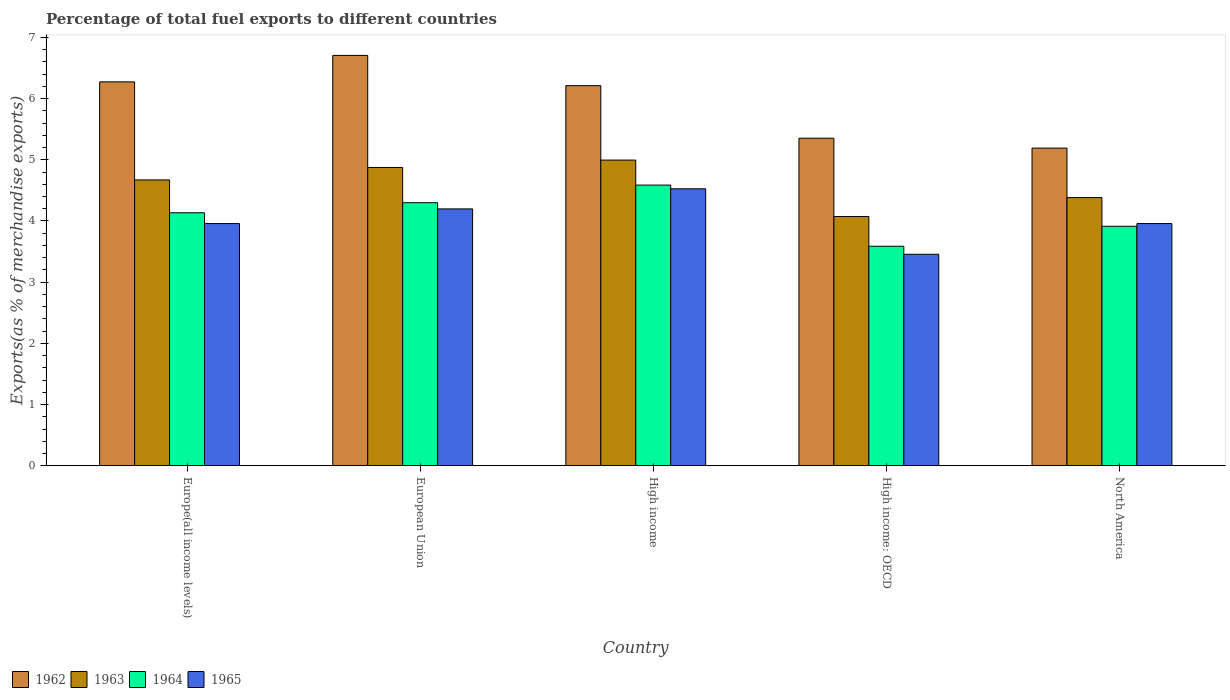Are the number of bars per tick equal to the number of legend labels?
Ensure brevity in your answer.  Yes. Are the number of bars on each tick of the X-axis equal?
Make the answer very short. Yes. How many bars are there on the 3rd tick from the left?
Offer a terse response. 4. How many bars are there on the 3rd tick from the right?
Provide a succinct answer. 4. What is the label of the 3rd group of bars from the left?
Offer a very short reply. High income. What is the percentage of exports to different countries in 1964 in High income?
Your answer should be very brief. 4.59. Across all countries, what is the maximum percentage of exports to different countries in 1962?
Ensure brevity in your answer.  6.71. Across all countries, what is the minimum percentage of exports to different countries in 1964?
Your answer should be very brief. 3.59. In which country was the percentage of exports to different countries in 1965 minimum?
Ensure brevity in your answer.  High income: OECD. What is the total percentage of exports to different countries in 1962 in the graph?
Keep it short and to the point. 29.73. What is the difference between the percentage of exports to different countries in 1962 in High income: OECD and that in North America?
Your answer should be very brief. 0.16. What is the difference between the percentage of exports to different countries in 1965 in High income: OECD and the percentage of exports to different countries in 1964 in North America?
Make the answer very short. -0.46. What is the average percentage of exports to different countries in 1963 per country?
Provide a succinct answer. 4.6. What is the difference between the percentage of exports to different countries of/in 1965 and percentage of exports to different countries of/in 1962 in North America?
Offer a very short reply. -1.23. In how many countries, is the percentage of exports to different countries in 1963 greater than 5.6 %?
Your response must be concise. 0. What is the ratio of the percentage of exports to different countries in 1965 in High income to that in High income: OECD?
Make the answer very short. 1.31. Is the percentage of exports to different countries in 1964 in High income: OECD less than that in North America?
Provide a short and direct response. Yes. Is the difference between the percentage of exports to different countries in 1965 in European Union and North America greater than the difference between the percentage of exports to different countries in 1962 in European Union and North America?
Make the answer very short. No. What is the difference between the highest and the second highest percentage of exports to different countries in 1963?
Provide a short and direct response. -0.32. What is the difference between the highest and the lowest percentage of exports to different countries in 1964?
Your answer should be very brief. 1. What does the 4th bar from the left in North America represents?
Keep it short and to the point. 1965. What does the 4th bar from the right in North America represents?
Ensure brevity in your answer.  1962. Are all the bars in the graph horizontal?
Offer a very short reply. No. What is the difference between two consecutive major ticks on the Y-axis?
Provide a succinct answer. 1. Are the values on the major ticks of Y-axis written in scientific E-notation?
Give a very brief answer. No. Does the graph contain any zero values?
Provide a succinct answer. No. How are the legend labels stacked?
Keep it short and to the point. Horizontal. What is the title of the graph?
Your response must be concise. Percentage of total fuel exports to different countries. What is the label or title of the X-axis?
Give a very brief answer. Country. What is the label or title of the Y-axis?
Provide a short and direct response. Exports(as % of merchandise exports). What is the Exports(as % of merchandise exports) in 1962 in Europe(all income levels)?
Provide a short and direct response. 6.27. What is the Exports(as % of merchandise exports) in 1963 in Europe(all income levels)?
Ensure brevity in your answer.  4.67. What is the Exports(as % of merchandise exports) of 1964 in Europe(all income levels)?
Ensure brevity in your answer.  4.13. What is the Exports(as % of merchandise exports) of 1965 in Europe(all income levels)?
Keep it short and to the point. 3.96. What is the Exports(as % of merchandise exports) of 1962 in European Union?
Keep it short and to the point. 6.71. What is the Exports(as % of merchandise exports) in 1963 in European Union?
Provide a short and direct response. 4.87. What is the Exports(as % of merchandise exports) in 1964 in European Union?
Your answer should be very brief. 4.3. What is the Exports(as % of merchandise exports) in 1965 in European Union?
Ensure brevity in your answer.  4.2. What is the Exports(as % of merchandise exports) in 1962 in High income?
Offer a very short reply. 6.21. What is the Exports(as % of merchandise exports) of 1963 in High income?
Your answer should be compact. 5. What is the Exports(as % of merchandise exports) of 1964 in High income?
Your answer should be compact. 4.59. What is the Exports(as % of merchandise exports) in 1965 in High income?
Give a very brief answer. 4.53. What is the Exports(as % of merchandise exports) of 1962 in High income: OECD?
Give a very brief answer. 5.35. What is the Exports(as % of merchandise exports) in 1963 in High income: OECD?
Your response must be concise. 4.07. What is the Exports(as % of merchandise exports) of 1964 in High income: OECD?
Provide a succinct answer. 3.59. What is the Exports(as % of merchandise exports) in 1965 in High income: OECD?
Keep it short and to the point. 3.46. What is the Exports(as % of merchandise exports) of 1962 in North America?
Your response must be concise. 5.19. What is the Exports(as % of merchandise exports) of 1963 in North America?
Offer a very short reply. 4.38. What is the Exports(as % of merchandise exports) in 1964 in North America?
Your answer should be very brief. 3.91. What is the Exports(as % of merchandise exports) in 1965 in North America?
Provide a short and direct response. 3.96. Across all countries, what is the maximum Exports(as % of merchandise exports) in 1962?
Offer a very short reply. 6.71. Across all countries, what is the maximum Exports(as % of merchandise exports) in 1963?
Keep it short and to the point. 5. Across all countries, what is the maximum Exports(as % of merchandise exports) of 1964?
Make the answer very short. 4.59. Across all countries, what is the maximum Exports(as % of merchandise exports) in 1965?
Give a very brief answer. 4.53. Across all countries, what is the minimum Exports(as % of merchandise exports) in 1962?
Your answer should be very brief. 5.19. Across all countries, what is the minimum Exports(as % of merchandise exports) of 1963?
Your response must be concise. 4.07. Across all countries, what is the minimum Exports(as % of merchandise exports) of 1964?
Make the answer very short. 3.59. Across all countries, what is the minimum Exports(as % of merchandise exports) of 1965?
Provide a succinct answer. 3.46. What is the total Exports(as % of merchandise exports) in 1962 in the graph?
Provide a succinct answer. 29.73. What is the total Exports(as % of merchandise exports) of 1963 in the graph?
Provide a succinct answer. 23. What is the total Exports(as % of merchandise exports) in 1964 in the graph?
Give a very brief answer. 20.52. What is the total Exports(as % of merchandise exports) of 1965 in the graph?
Your answer should be very brief. 20.09. What is the difference between the Exports(as % of merchandise exports) of 1962 in Europe(all income levels) and that in European Union?
Give a very brief answer. -0.43. What is the difference between the Exports(as % of merchandise exports) in 1963 in Europe(all income levels) and that in European Union?
Your response must be concise. -0.2. What is the difference between the Exports(as % of merchandise exports) of 1964 in Europe(all income levels) and that in European Union?
Give a very brief answer. -0.16. What is the difference between the Exports(as % of merchandise exports) of 1965 in Europe(all income levels) and that in European Union?
Ensure brevity in your answer.  -0.24. What is the difference between the Exports(as % of merchandise exports) of 1962 in Europe(all income levels) and that in High income?
Your response must be concise. 0.06. What is the difference between the Exports(as % of merchandise exports) of 1963 in Europe(all income levels) and that in High income?
Provide a succinct answer. -0.32. What is the difference between the Exports(as % of merchandise exports) of 1964 in Europe(all income levels) and that in High income?
Your answer should be compact. -0.45. What is the difference between the Exports(as % of merchandise exports) of 1965 in Europe(all income levels) and that in High income?
Provide a short and direct response. -0.57. What is the difference between the Exports(as % of merchandise exports) in 1962 in Europe(all income levels) and that in High income: OECD?
Your answer should be very brief. 0.92. What is the difference between the Exports(as % of merchandise exports) in 1963 in Europe(all income levels) and that in High income: OECD?
Ensure brevity in your answer.  0.6. What is the difference between the Exports(as % of merchandise exports) of 1964 in Europe(all income levels) and that in High income: OECD?
Provide a succinct answer. 0.55. What is the difference between the Exports(as % of merchandise exports) in 1965 in Europe(all income levels) and that in High income: OECD?
Your answer should be compact. 0.5. What is the difference between the Exports(as % of merchandise exports) of 1962 in Europe(all income levels) and that in North America?
Your answer should be compact. 1.08. What is the difference between the Exports(as % of merchandise exports) of 1963 in Europe(all income levels) and that in North America?
Make the answer very short. 0.29. What is the difference between the Exports(as % of merchandise exports) in 1964 in Europe(all income levels) and that in North America?
Your answer should be compact. 0.22. What is the difference between the Exports(as % of merchandise exports) of 1965 in Europe(all income levels) and that in North America?
Your response must be concise. 0. What is the difference between the Exports(as % of merchandise exports) in 1962 in European Union and that in High income?
Keep it short and to the point. 0.49. What is the difference between the Exports(as % of merchandise exports) of 1963 in European Union and that in High income?
Provide a short and direct response. -0.12. What is the difference between the Exports(as % of merchandise exports) in 1964 in European Union and that in High income?
Your answer should be compact. -0.29. What is the difference between the Exports(as % of merchandise exports) of 1965 in European Union and that in High income?
Keep it short and to the point. -0.33. What is the difference between the Exports(as % of merchandise exports) of 1962 in European Union and that in High income: OECD?
Keep it short and to the point. 1.35. What is the difference between the Exports(as % of merchandise exports) in 1963 in European Union and that in High income: OECD?
Give a very brief answer. 0.8. What is the difference between the Exports(as % of merchandise exports) in 1964 in European Union and that in High income: OECD?
Give a very brief answer. 0.71. What is the difference between the Exports(as % of merchandise exports) in 1965 in European Union and that in High income: OECD?
Your answer should be compact. 0.74. What is the difference between the Exports(as % of merchandise exports) of 1962 in European Union and that in North America?
Make the answer very short. 1.52. What is the difference between the Exports(as % of merchandise exports) of 1963 in European Union and that in North America?
Your response must be concise. 0.49. What is the difference between the Exports(as % of merchandise exports) of 1964 in European Union and that in North America?
Your response must be concise. 0.39. What is the difference between the Exports(as % of merchandise exports) in 1965 in European Union and that in North America?
Your response must be concise. 0.24. What is the difference between the Exports(as % of merchandise exports) in 1962 in High income and that in High income: OECD?
Your response must be concise. 0.86. What is the difference between the Exports(as % of merchandise exports) in 1963 in High income and that in High income: OECD?
Provide a succinct answer. 0.92. What is the difference between the Exports(as % of merchandise exports) of 1965 in High income and that in High income: OECD?
Give a very brief answer. 1.07. What is the difference between the Exports(as % of merchandise exports) in 1962 in High income and that in North America?
Provide a succinct answer. 1.02. What is the difference between the Exports(as % of merchandise exports) in 1963 in High income and that in North America?
Offer a very short reply. 0.61. What is the difference between the Exports(as % of merchandise exports) in 1964 in High income and that in North America?
Ensure brevity in your answer.  0.67. What is the difference between the Exports(as % of merchandise exports) of 1965 in High income and that in North America?
Your response must be concise. 0.57. What is the difference between the Exports(as % of merchandise exports) in 1962 in High income: OECD and that in North America?
Make the answer very short. 0.16. What is the difference between the Exports(as % of merchandise exports) of 1963 in High income: OECD and that in North America?
Provide a succinct answer. -0.31. What is the difference between the Exports(as % of merchandise exports) in 1964 in High income: OECD and that in North America?
Your answer should be compact. -0.33. What is the difference between the Exports(as % of merchandise exports) of 1965 in High income: OECD and that in North America?
Offer a terse response. -0.5. What is the difference between the Exports(as % of merchandise exports) in 1962 in Europe(all income levels) and the Exports(as % of merchandise exports) in 1963 in European Union?
Provide a succinct answer. 1.4. What is the difference between the Exports(as % of merchandise exports) of 1962 in Europe(all income levels) and the Exports(as % of merchandise exports) of 1964 in European Union?
Offer a terse response. 1.97. What is the difference between the Exports(as % of merchandise exports) in 1962 in Europe(all income levels) and the Exports(as % of merchandise exports) in 1965 in European Union?
Offer a terse response. 2.08. What is the difference between the Exports(as % of merchandise exports) of 1963 in Europe(all income levels) and the Exports(as % of merchandise exports) of 1964 in European Union?
Offer a very short reply. 0.37. What is the difference between the Exports(as % of merchandise exports) of 1963 in Europe(all income levels) and the Exports(as % of merchandise exports) of 1965 in European Union?
Your response must be concise. 0.47. What is the difference between the Exports(as % of merchandise exports) in 1964 in Europe(all income levels) and the Exports(as % of merchandise exports) in 1965 in European Union?
Your answer should be very brief. -0.06. What is the difference between the Exports(as % of merchandise exports) in 1962 in Europe(all income levels) and the Exports(as % of merchandise exports) in 1963 in High income?
Ensure brevity in your answer.  1.28. What is the difference between the Exports(as % of merchandise exports) in 1962 in Europe(all income levels) and the Exports(as % of merchandise exports) in 1964 in High income?
Offer a terse response. 1.69. What is the difference between the Exports(as % of merchandise exports) in 1962 in Europe(all income levels) and the Exports(as % of merchandise exports) in 1965 in High income?
Your answer should be compact. 1.75. What is the difference between the Exports(as % of merchandise exports) of 1963 in Europe(all income levels) and the Exports(as % of merchandise exports) of 1964 in High income?
Offer a very short reply. 0.08. What is the difference between the Exports(as % of merchandise exports) in 1963 in Europe(all income levels) and the Exports(as % of merchandise exports) in 1965 in High income?
Your answer should be compact. 0.15. What is the difference between the Exports(as % of merchandise exports) in 1964 in Europe(all income levels) and the Exports(as % of merchandise exports) in 1965 in High income?
Your answer should be very brief. -0.39. What is the difference between the Exports(as % of merchandise exports) in 1962 in Europe(all income levels) and the Exports(as % of merchandise exports) in 1963 in High income: OECD?
Ensure brevity in your answer.  2.2. What is the difference between the Exports(as % of merchandise exports) in 1962 in Europe(all income levels) and the Exports(as % of merchandise exports) in 1964 in High income: OECD?
Your response must be concise. 2.69. What is the difference between the Exports(as % of merchandise exports) in 1962 in Europe(all income levels) and the Exports(as % of merchandise exports) in 1965 in High income: OECD?
Your answer should be compact. 2.82. What is the difference between the Exports(as % of merchandise exports) of 1963 in Europe(all income levels) and the Exports(as % of merchandise exports) of 1964 in High income: OECD?
Offer a terse response. 1.08. What is the difference between the Exports(as % of merchandise exports) of 1963 in Europe(all income levels) and the Exports(as % of merchandise exports) of 1965 in High income: OECD?
Provide a succinct answer. 1.22. What is the difference between the Exports(as % of merchandise exports) of 1964 in Europe(all income levels) and the Exports(as % of merchandise exports) of 1965 in High income: OECD?
Keep it short and to the point. 0.68. What is the difference between the Exports(as % of merchandise exports) in 1962 in Europe(all income levels) and the Exports(as % of merchandise exports) in 1963 in North America?
Your answer should be compact. 1.89. What is the difference between the Exports(as % of merchandise exports) of 1962 in Europe(all income levels) and the Exports(as % of merchandise exports) of 1964 in North America?
Provide a succinct answer. 2.36. What is the difference between the Exports(as % of merchandise exports) in 1962 in Europe(all income levels) and the Exports(as % of merchandise exports) in 1965 in North America?
Provide a short and direct response. 2.32. What is the difference between the Exports(as % of merchandise exports) of 1963 in Europe(all income levels) and the Exports(as % of merchandise exports) of 1964 in North America?
Your answer should be compact. 0.76. What is the difference between the Exports(as % of merchandise exports) of 1963 in Europe(all income levels) and the Exports(as % of merchandise exports) of 1965 in North America?
Your answer should be very brief. 0.71. What is the difference between the Exports(as % of merchandise exports) of 1964 in Europe(all income levels) and the Exports(as % of merchandise exports) of 1965 in North America?
Ensure brevity in your answer.  0.18. What is the difference between the Exports(as % of merchandise exports) of 1962 in European Union and the Exports(as % of merchandise exports) of 1963 in High income?
Offer a terse response. 1.71. What is the difference between the Exports(as % of merchandise exports) in 1962 in European Union and the Exports(as % of merchandise exports) in 1964 in High income?
Provide a short and direct response. 2.12. What is the difference between the Exports(as % of merchandise exports) of 1962 in European Union and the Exports(as % of merchandise exports) of 1965 in High income?
Ensure brevity in your answer.  2.18. What is the difference between the Exports(as % of merchandise exports) of 1963 in European Union and the Exports(as % of merchandise exports) of 1964 in High income?
Your response must be concise. 0.29. What is the difference between the Exports(as % of merchandise exports) in 1963 in European Union and the Exports(as % of merchandise exports) in 1965 in High income?
Make the answer very short. 0.35. What is the difference between the Exports(as % of merchandise exports) of 1964 in European Union and the Exports(as % of merchandise exports) of 1965 in High income?
Your response must be concise. -0.23. What is the difference between the Exports(as % of merchandise exports) in 1962 in European Union and the Exports(as % of merchandise exports) in 1963 in High income: OECD?
Give a very brief answer. 2.63. What is the difference between the Exports(as % of merchandise exports) in 1962 in European Union and the Exports(as % of merchandise exports) in 1964 in High income: OECD?
Your response must be concise. 3.12. What is the difference between the Exports(as % of merchandise exports) of 1962 in European Union and the Exports(as % of merchandise exports) of 1965 in High income: OECD?
Provide a succinct answer. 3.25. What is the difference between the Exports(as % of merchandise exports) of 1963 in European Union and the Exports(as % of merchandise exports) of 1964 in High income: OECD?
Your response must be concise. 1.29. What is the difference between the Exports(as % of merchandise exports) in 1963 in European Union and the Exports(as % of merchandise exports) in 1965 in High income: OECD?
Your answer should be very brief. 1.42. What is the difference between the Exports(as % of merchandise exports) of 1964 in European Union and the Exports(as % of merchandise exports) of 1965 in High income: OECD?
Give a very brief answer. 0.84. What is the difference between the Exports(as % of merchandise exports) in 1962 in European Union and the Exports(as % of merchandise exports) in 1963 in North America?
Your answer should be very brief. 2.32. What is the difference between the Exports(as % of merchandise exports) in 1962 in European Union and the Exports(as % of merchandise exports) in 1964 in North America?
Provide a succinct answer. 2.79. What is the difference between the Exports(as % of merchandise exports) in 1962 in European Union and the Exports(as % of merchandise exports) in 1965 in North America?
Provide a succinct answer. 2.75. What is the difference between the Exports(as % of merchandise exports) in 1963 in European Union and the Exports(as % of merchandise exports) in 1964 in North America?
Ensure brevity in your answer.  0.96. What is the difference between the Exports(as % of merchandise exports) in 1963 in European Union and the Exports(as % of merchandise exports) in 1965 in North America?
Make the answer very short. 0.92. What is the difference between the Exports(as % of merchandise exports) of 1964 in European Union and the Exports(as % of merchandise exports) of 1965 in North America?
Keep it short and to the point. 0.34. What is the difference between the Exports(as % of merchandise exports) in 1962 in High income and the Exports(as % of merchandise exports) in 1963 in High income: OECD?
Ensure brevity in your answer.  2.14. What is the difference between the Exports(as % of merchandise exports) of 1962 in High income and the Exports(as % of merchandise exports) of 1964 in High income: OECD?
Provide a short and direct response. 2.62. What is the difference between the Exports(as % of merchandise exports) of 1962 in High income and the Exports(as % of merchandise exports) of 1965 in High income: OECD?
Provide a succinct answer. 2.76. What is the difference between the Exports(as % of merchandise exports) in 1963 in High income and the Exports(as % of merchandise exports) in 1964 in High income: OECD?
Give a very brief answer. 1.41. What is the difference between the Exports(as % of merchandise exports) of 1963 in High income and the Exports(as % of merchandise exports) of 1965 in High income: OECD?
Your answer should be very brief. 1.54. What is the difference between the Exports(as % of merchandise exports) of 1964 in High income and the Exports(as % of merchandise exports) of 1965 in High income: OECD?
Your answer should be compact. 1.13. What is the difference between the Exports(as % of merchandise exports) of 1962 in High income and the Exports(as % of merchandise exports) of 1963 in North America?
Keep it short and to the point. 1.83. What is the difference between the Exports(as % of merchandise exports) in 1962 in High income and the Exports(as % of merchandise exports) in 1964 in North America?
Ensure brevity in your answer.  2.3. What is the difference between the Exports(as % of merchandise exports) of 1962 in High income and the Exports(as % of merchandise exports) of 1965 in North America?
Offer a very short reply. 2.25. What is the difference between the Exports(as % of merchandise exports) in 1963 in High income and the Exports(as % of merchandise exports) in 1964 in North America?
Give a very brief answer. 1.08. What is the difference between the Exports(as % of merchandise exports) in 1963 in High income and the Exports(as % of merchandise exports) in 1965 in North America?
Offer a very short reply. 1.04. What is the difference between the Exports(as % of merchandise exports) in 1964 in High income and the Exports(as % of merchandise exports) in 1965 in North America?
Make the answer very short. 0.63. What is the difference between the Exports(as % of merchandise exports) in 1962 in High income: OECD and the Exports(as % of merchandise exports) in 1963 in North America?
Your answer should be very brief. 0.97. What is the difference between the Exports(as % of merchandise exports) of 1962 in High income: OECD and the Exports(as % of merchandise exports) of 1964 in North America?
Your answer should be compact. 1.44. What is the difference between the Exports(as % of merchandise exports) in 1962 in High income: OECD and the Exports(as % of merchandise exports) in 1965 in North America?
Make the answer very short. 1.39. What is the difference between the Exports(as % of merchandise exports) in 1963 in High income: OECD and the Exports(as % of merchandise exports) in 1964 in North America?
Your response must be concise. 0.16. What is the difference between the Exports(as % of merchandise exports) of 1963 in High income: OECD and the Exports(as % of merchandise exports) of 1965 in North America?
Keep it short and to the point. 0.12. What is the difference between the Exports(as % of merchandise exports) in 1964 in High income: OECD and the Exports(as % of merchandise exports) in 1965 in North America?
Make the answer very short. -0.37. What is the average Exports(as % of merchandise exports) in 1962 per country?
Give a very brief answer. 5.95. What is the average Exports(as % of merchandise exports) in 1963 per country?
Offer a very short reply. 4.6. What is the average Exports(as % of merchandise exports) of 1964 per country?
Keep it short and to the point. 4.1. What is the average Exports(as % of merchandise exports) in 1965 per country?
Give a very brief answer. 4.02. What is the difference between the Exports(as % of merchandise exports) in 1962 and Exports(as % of merchandise exports) in 1963 in Europe(all income levels)?
Give a very brief answer. 1.6. What is the difference between the Exports(as % of merchandise exports) in 1962 and Exports(as % of merchandise exports) in 1964 in Europe(all income levels)?
Your answer should be very brief. 2.14. What is the difference between the Exports(as % of merchandise exports) in 1962 and Exports(as % of merchandise exports) in 1965 in Europe(all income levels)?
Provide a short and direct response. 2.32. What is the difference between the Exports(as % of merchandise exports) in 1963 and Exports(as % of merchandise exports) in 1964 in Europe(all income levels)?
Offer a very short reply. 0.54. What is the difference between the Exports(as % of merchandise exports) of 1963 and Exports(as % of merchandise exports) of 1965 in Europe(all income levels)?
Offer a terse response. 0.71. What is the difference between the Exports(as % of merchandise exports) of 1964 and Exports(as % of merchandise exports) of 1965 in Europe(all income levels)?
Give a very brief answer. 0.18. What is the difference between the Exports(as % of merchandise exports) in 1962 and Exports(as % of merchandise exports) in 1963 in European Union?
Your response must be concise. 1.83. What is the difference between the Exports(as % of merchandise exports) in 1962 and Exports(as % of merchandise exports) in 1964 in European Union?
Offer a terse response. 2.41. What is the difference between the Exports(as % of merchandise exports) of 1962 and Exports(as % of merchandise exports) of 1965 in European Union?
Provide a succinct answer. 2.51. What is the difference between the Exports(as % of merchandise exports) of 1963 and Exports(as % of merchandise exports) of 1964 in European Union?
Give a very brief answer. 0.58. What is the difference between the Exports(as % of merchandise exports) in 1963 and Exports(as % of merchandise exports) in 1965 in European Union?
Give a very brief answer. 0.68. What is the difference between the Exports(as % of merchandise exports) in 1964 and Exports(as % of merchandise exports) in 1965 in European Union?
Offer a terse response. 0.1. What is the difference between the Exports(as % of merchandise exports) of 1962 and Exports(as % of merchandise exports) of 1963 in High income?
Give a very brief answer. 1.22. What is the difference between the Exports(as % of merchandise exports) in 1962 and Exports(as % of merchandise exports) in 1964 in High income?
Keep it short and to the point. 1.63. What is the difference between the Exports(as % of merchandise exports) of 1962 and Exports(as % of merchandise exports) of 1965 in High income?
Your answer should be very brief. 1.69. What is the difference between the Exports(as % of merchandise exports) of 1963 and Exports(as % of merchandise exports) of 1964 in High income?
Keep it short and to the point. 0.41. What is the difference between the Exports(as % of merchandise exports) of 1963 and Exports(as % of merchandise exports) of 1965 in High income?
Your response must be concise. 0.47. What is the difference between the Exports(as % of merchandise exports) in 1964 and Exports(as % of merchandise exports) in 1965 in High income?
Make the answer very short. 0.06. What is the difference between the Exports(as % of merchandise exports) of 1962 and Exports(as % of merchandise exports) of 1963 in High income: OECD?
Give a very brief answer. 1.28. What is the difference between the Exports(as % of merchandise exports) in 1962 and Exports(as % of merchandise exports) in 1964 in High income: OECD?
Provide a short and direct response. 1.77. What is the difference between the Exports(as % of merchandise exports) of 1962 and Exports(as % of merchandise exports) of 1965 in High income: OECD?
Offer a very short reply. 1.9. What is the difference between the Exports(as % of merchandise exports) in 1963 and Exports(as % of merchandise exports) in 1964 in High income: OECD?
Ensure brevity in your answer.  0.49. What is the difference between the Exports(as % of merchandise exports) in 1963 and Exports(as % of merchandise exports) in 1965 in High income: OECD?
Give a very brief answer. 0.62. What is the difference between the Exports(as % of merchandise exports) of 1964 and Exports(as % of merchandise exports) of 1965 in High income: OECD?
Your answer should be compact. 0.13. What is the difference between the Exports(as % of merchandise exports) of 1962 and Exports(as % of merchandise exports) of 1963 in North America?
Make the answer very short. 0.81. What is the difference between the Exports(as % of merchandise exports) in 1962 and Exports(as % of merchandise exports) in 1964 in North America?
Ensure brevity in your answer.  1.28. What is the difference between the Exports(as % of merchandise exports) in 1962 and Exports(as % of merchandise exports) in 1965 in North America?
Your answer should be compact. 1.23. What is the difference between the Exports(as % of merchandise exports) of 1963 and Exports(as % of merchandise exports) of 1964 in North America?
Give a very brief answer. 0.47. What is the difference between the Exports(as % of merchandise exports) in 1963 and Exports(as % of merchandise exports) in 1965 in North America?
Your answer should be compact. 0.42. What is the difference between the Exports(as % of merchandise exports) in 1964 and Exports(as % of merchandise exports) in 1965 in North America?
Your answer should be very brief. -0.04. What is the ratio of the Exports(as % of merchandise exports) in 1962 in Europe(all income levels) to that in European Union?
Make the answer very short. 0.94. What is the ratio of the Exports(as % of merchandise exports) of 1963 in Europe(all income levels) to that in European Union?
Your answer should be very brief. 0.96. What is the ratio of the Exports(as % of merchandise exports) of 1964 in Europe(all income levels) to that in European Union?
Make the answer very short. 0.96. What is the ratio of the Exports(as % of merchandise exports) of 1965 in Europe(all income levels) to that in European Union?
Give a very brief answer. 0.94. What is the ratio of the Exports(as % of merchandise exports) in 1962 in Europe(all income levels) to that in High income?
Give a very brief answer. 1.01. What is the ratio of the Exports(as % of merchandise exports) in 1963 in Europe(all income levels) to that in High income?
Provide a short and direct response. 0.94. What is the ratio of the Exports(as % of merchandise exports) of 1964 in Europe(all income levels) to that in High income?
Keep it short and to the point. 0.9. What is the ratio of the Exports(as % of merchandise exports) of 1965 in Europe(all income levels) to that in High income?
Make the answer very short. 0.87. What is the ratio of the Exports(as % of merchandise exports) of 1962 in Europe(all income levels) to that in High income: OECD?
Give a very brief answer. 1.17. What is the ratio of the Exports(as % of merchandise exports) of 1963 in Europe(all income levels) to that in High income: OECD?
Give a very brief answer. 1.15. What is the ratio of the Exports(as % of merchandise exports) of 1964 in Europe(all income levels) to that in High income: OECD?
Your answer should be very brief. 1.15. What is the ratio of the Exports(as % of merchandise exports) in 1965 in Europe(all income levels) to that in High income: OECD?
Ensure brevity in your answer.  1.15. What is the ratio of the Exports(as % of merchandise exports) in 1962 in Europe(all income levels) to that in North America?
Your response must be concise. 1.21. What is the ratio of the Exports(as % of merchandise exports) in 1963 in Europe(all income levels) to that in North America?
Give a very brief answer. 1.07. What is the ratio of the Exports(as % of merchandise exports) in 1964 in Europe(all income levels) to that in North America?
Keep it short and to the point. 1.06. What is the ratio of the Exports(as % of merchandise exports) in 1965 in Europe(all income levels) to that in North America?
Your answer should be very brief. 1. What is the ratio of the Exports(as % of merchandise exports) in 1962 in European Union to that in High income?
Offer a terse response. 1.08. What is the ratio of the Exports(as % of merchandise exports) in 1963 in European Union to that in High income?
Your response must be concise. 0.98. What is the ratio of the Exports(as % of merchandise exports) in 1964 in European Union to that in High income?
Your answer should be very brief. 0.94. What is the ratio of the Exports(as % of merchandise exports) in 1965 in European Union to that in High income?
Give a very brief answer. 0.93. What is the ratio of the Exports(as % of merchandise exports) in 1962 in European Union to that in High income: OECD?
Provide a succinct answer. 1.25. What is the ratio of the Exports(as % of merchandise exports) in 1963 in European Union to that in High income: OECD?
Offer a terse response. 1.2. What is the ratio of the Exports(as % of merchandise exports) in 1964 in European Union to that in High income: OECD?
Keep it short and to the point. 1.2. What is the ratio of the Exports(as % of merchandise exports) in 1965 in European Union to that in High income: OECD?
Keep it short and to the point. 1.21. What is the ratio of the Exports(as % of merchandise exports) in 1962 in European Union to that in North America?
Give a very brief answer. 1.29. What is the ratio of the Exports(as % of merchandise exports) in 1963 in European Union to that in North America?
Your answer should be compact. 1.11. What is the ratio of the Exports(as % of merchandise exports) of 1964 in European Union to that in North America?
Offer a very short reply. 1.1. What is the ratio of the Exports(as % of merchandise exports) of 1965 in European Union to that in North America?
Your answer should be compact. 1.06. What is the ratio of the Exports(as % of merchandise exports) of 1962 in High income to that in High income: OECD?
Provide a short and direct response. 1.16. What is the ratio of the Exports(as % of merchandise exports) in 1963 in High income to that in High income: OECD?
Provide a succinct answer. 1.23. What is the ratio of the Exports(as % of merchandise exports) of 1964 in High income to that in High income: OECD?
Your answer should be compact. 1.28. What is the ratio of the Exports(as % of merchandise exports) of 1965 in High income to that in High income: OECD?
Keep it short and to the point. 1.31. What is the ratio of the Exports(as % of merchandise exports) in 1962 in High income to that in North America?
Keep it short and to the point. 1.2. What is the ratio of the Exports(as % of merchandise exports) of 1963 in High income to that in North America?
Your answer should be compact. 1.14. What is the ratio of the Exports(as % of merchandise exports) of 1964 in High income to that in North America?
Offer a terse response. 1.17. What is the ratio of the Exports(as % of merchandise exports) in 1965 in High income to that in North America?
Keep it short and to the point. 1.14. What is the ratio of the Exports(as % of merchandise exports) in 1962 in High income: OECD to that in North America?
Make the answer very short. 1.03. What is the ratio of the Exports(as % of merchandise exports) of 1963 in High income: OECD to that in North America?
Keep it short and to the point. 0.93. What is the ratio of the Exports(as % of merchandise exports) in 1964 in High income: OECD to that in North America?
Your answer should be very brief. 0.92. What is the ratio of the Exports(as % of merchandise exports) of 1965 in High income: OECD to that in North America?
Offer a terse response. 0.87. What is the difference between the highest and the second highest Exports(as % of merchandise exports) in 1962?
Offer a terse response. 0.43. What is the difference between the highest and the second highest Exports(as % of merchandise exports) of 1963?
Make the answer very short. 0.12. What is the difference between the highest and the second highest Exports(as % of merchandise exports) of 1964?
Your response must be concise. 0.29. What is the difference between the highest and the second highest Exports(as % of merchandise exports) of 1965?
Offer a terse response. 0.33. What is the difference between the highest and the lowest Exports(as % of merchandise exports) in 1962?
Ensure brevity in your answer.  1.52. What is the difference between the highest and the lowest Exports(as % of merchandise exports) of 1963?
Your response must be concise. 0.92. What is the difference between the highest and the lowest Exports(as % of merchandise exports) of 1964?
Give a very brief answer. 1. What is the difference between the highest and the lowest Exports(as % of merchandise exports) in 1965?
Your response must be concise. 1.07. 